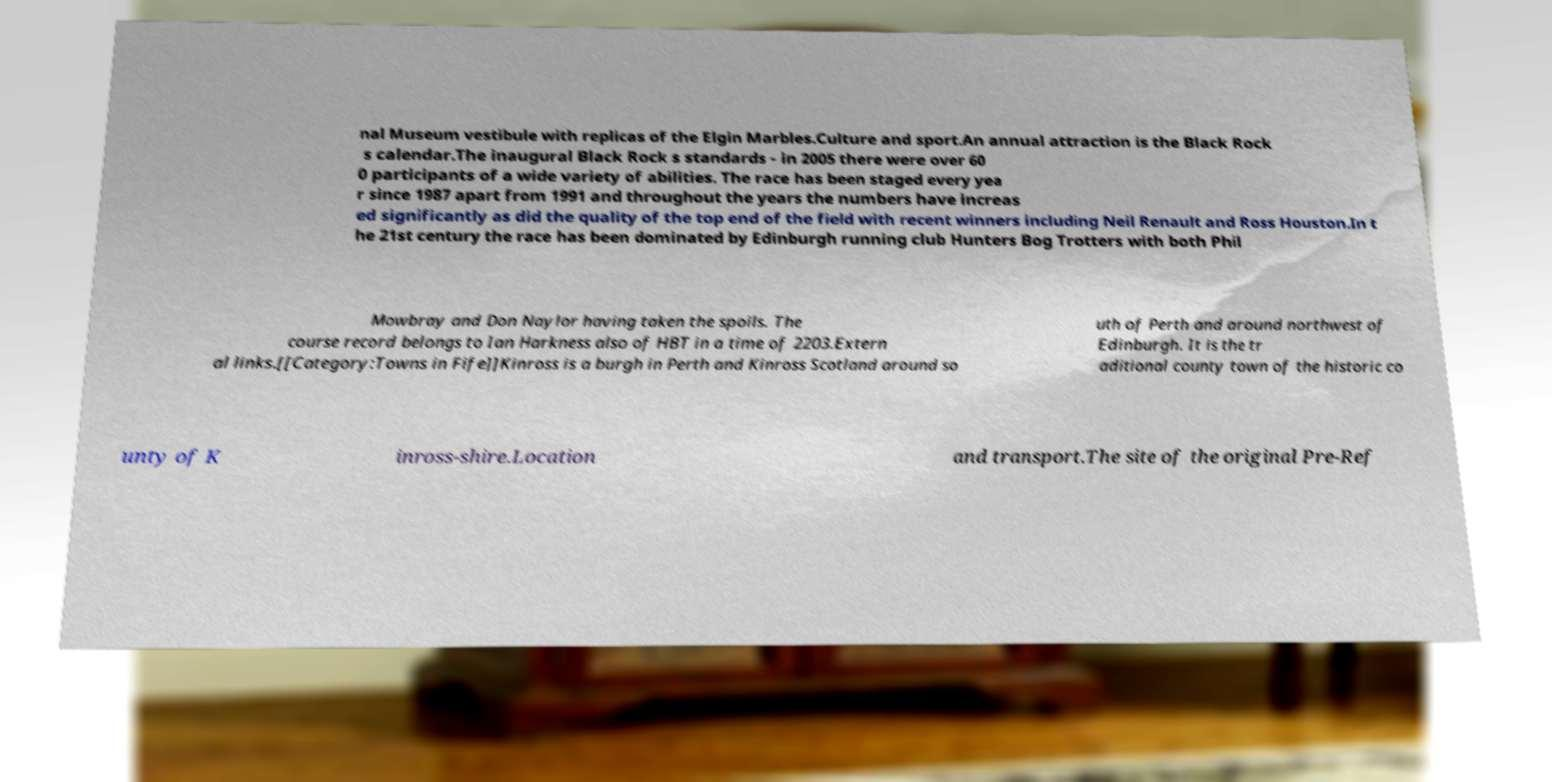Please read and relay the text visible in this image. What does it say? nal Museum vestibule with replicas of the Elgin Marbles.Culture and sport.An annual attraction is the Black Rock s calendar.The inaugural Black Rock s standards - in 2005 there were over 60 0 participants of a wide variety of abilities. The race has been staged every yea r since 1987 apart from 1991 and throughout the years the numbers have increas ed significantly as did the quality of the top end of the field with recent winners including Neil Renault and Ross Houston.In t he 21st century the race has been dominated by Edinburgh running club Hunters Bog Trotters with both Phil Mowbray and Don Naylor having taken the spoils. The course record belongs to Ian Harkness also of HBT in a time of 2203.Extern al links.[[Category:Towns in Fife]]Kinross is a burgh in Perth and Kinross Scotland around so uth of Perth and around northwest of Edinburgh. It is the tr aditional county town of the historic co unty of K inross-shire.Location and transport.The site of the original Pre-Ref 